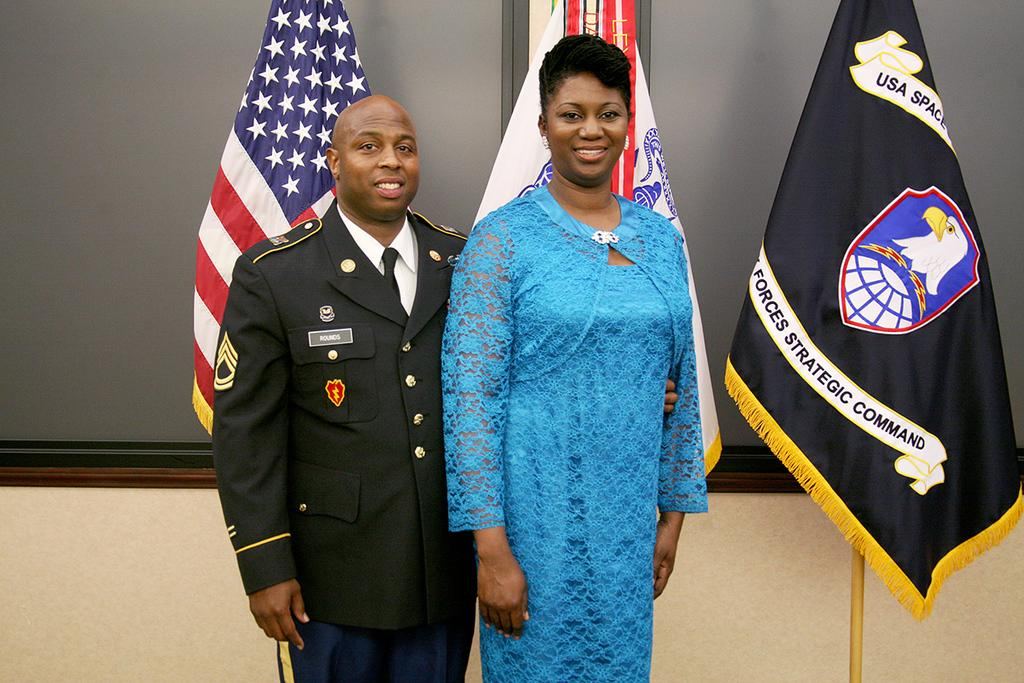<image>
Present a compact description of the photo's key features. A blue flag with an eagle reads USA SPACE. 